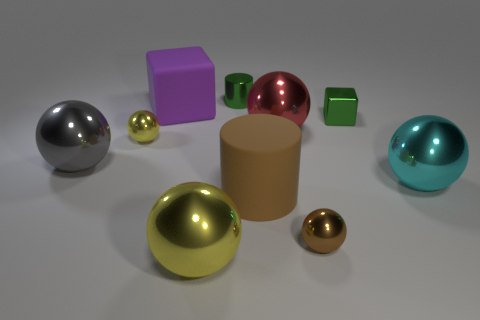There is a shiny object that is the same color as the small block; what shape is it?
Your answer should be very brief. Cylinder. Do the rubber object that is right of the tiny green cylinder and the tiny shiny cylinder that is behind the small green cube have the same color?
Give a very brief answer. No. What number of other objects are there of the same size as the purple rubber thing?
Ensure brevity in your answer.  5. Is there a large yellow sphere that is behind the cylinder right of the tiny green thing behind the big purple matte block?
Keep it short and to the point. No. Is the small green thing that is right of the big red sphere made of the same material as the large gray thing?
Make the answer very short. Yes. What color is the other small metal object that is the same shape as the brown metallic object?
Provide a short and direct response. Yellow. Is there anything else that has the same shape as the large gray thing?
Keep it short and to the point. Yes. Are there the same number of cyan metal objects on the right side of the big cyan ball and large shiny balls?
Give a very brief answer. No. There is a red shiny sphere; are there any big purple rubber things in front of it?
Offer a very short reply. No. How big is the yellow shiny sphere that is in front of the small metal sphere left of the small green metallic object that is behind the tiny green block?
Offer a very short reply. Large. 